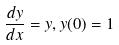<formula> <loc_0><loc_0><loc_500><loc_500>\frac { d y } { d x } = y , y ( 0 ) = 1</formula> 